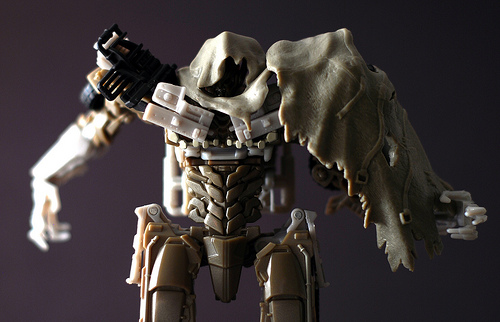<image>
Is the action figure to the left of the cloak? Yes. From this viewpoint, the action figure is positioned to the left side relative to the cloak. 